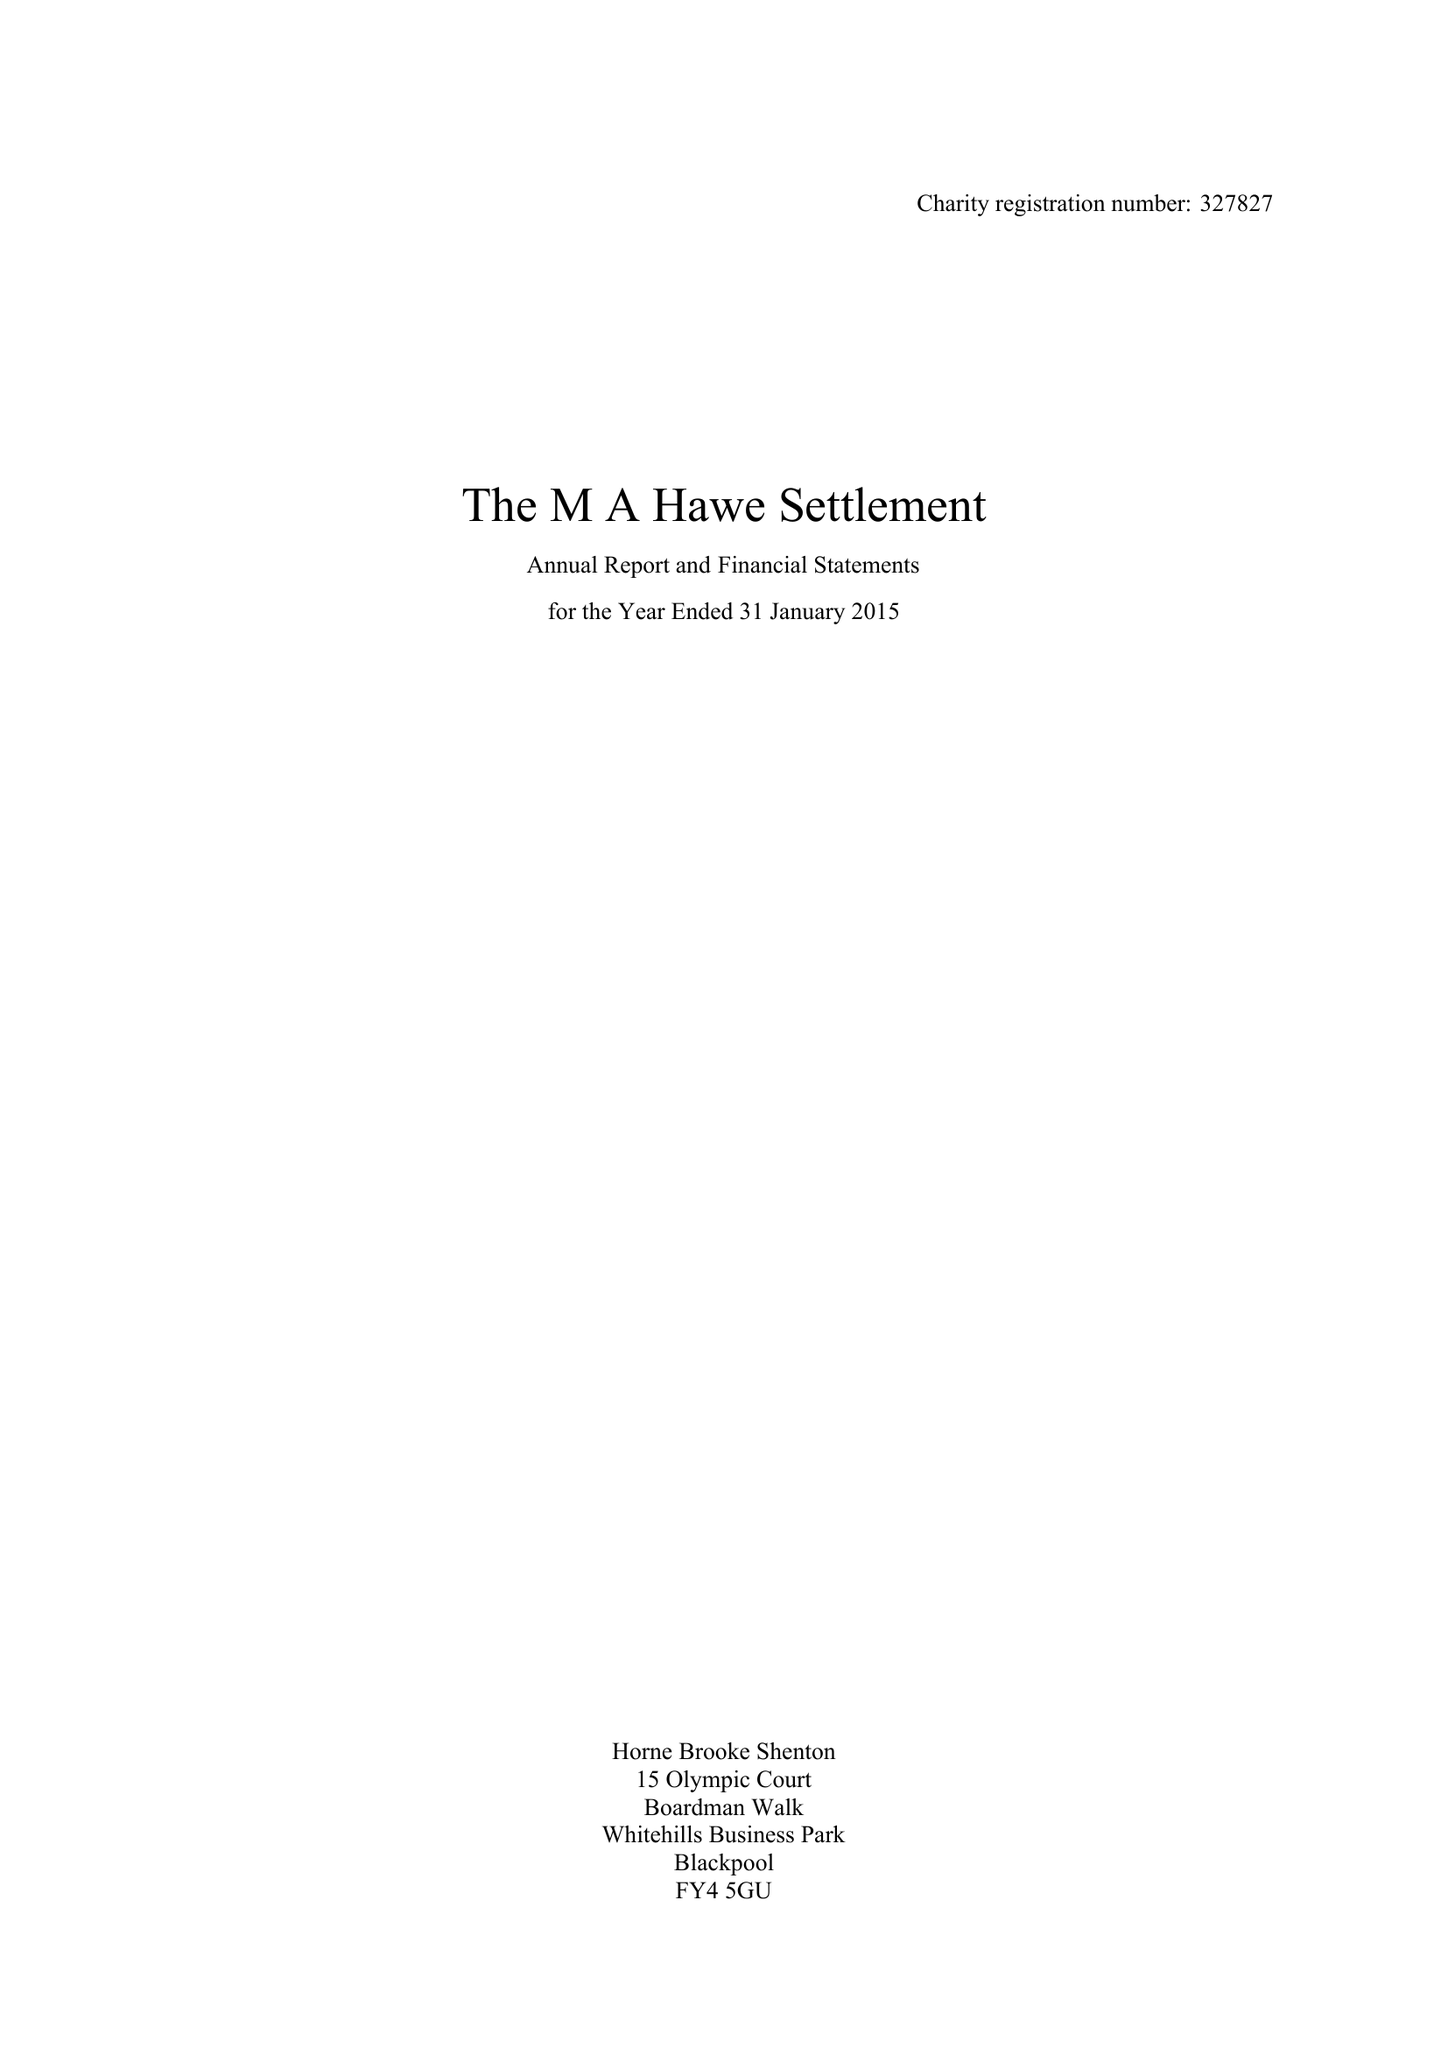What is the value for the spending_annually_in_british_pounds?
Answer the question using a single word or phrase. 268873.00 